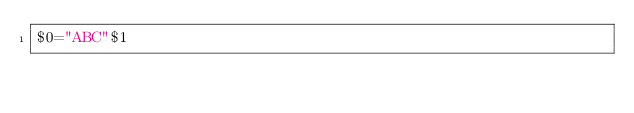Convert code to text. <code><loc_0><loc_0><loc_500><loc_500><_Awk_>$0="ABC"$1</code> 